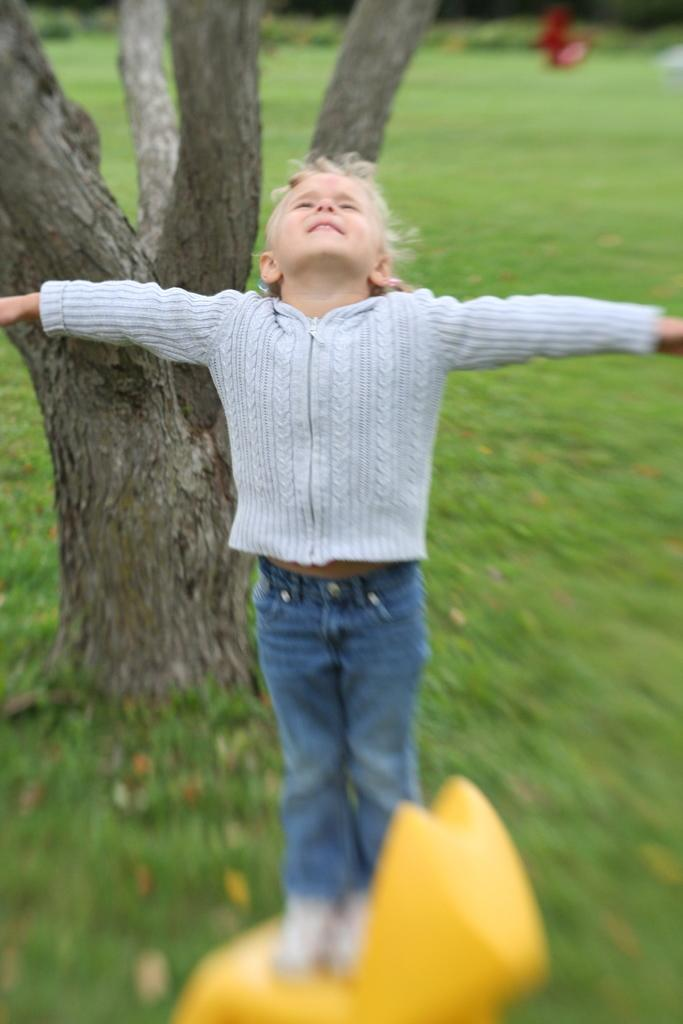What is the main subject of the image? There is a child in the image. What type of clothing is the child wearing? The child is wearing jean pants. What action is the child performing? The child is stretching both hands. What is the child standing on? The child is standing on a yellow object. What can be seen in the background of the image? There is a tree and grass on the ground in the background of the image. What type of window can be seen in the image? There is no window present in the image; it features a child standing on a yellow object with a tree and grass in the background. 